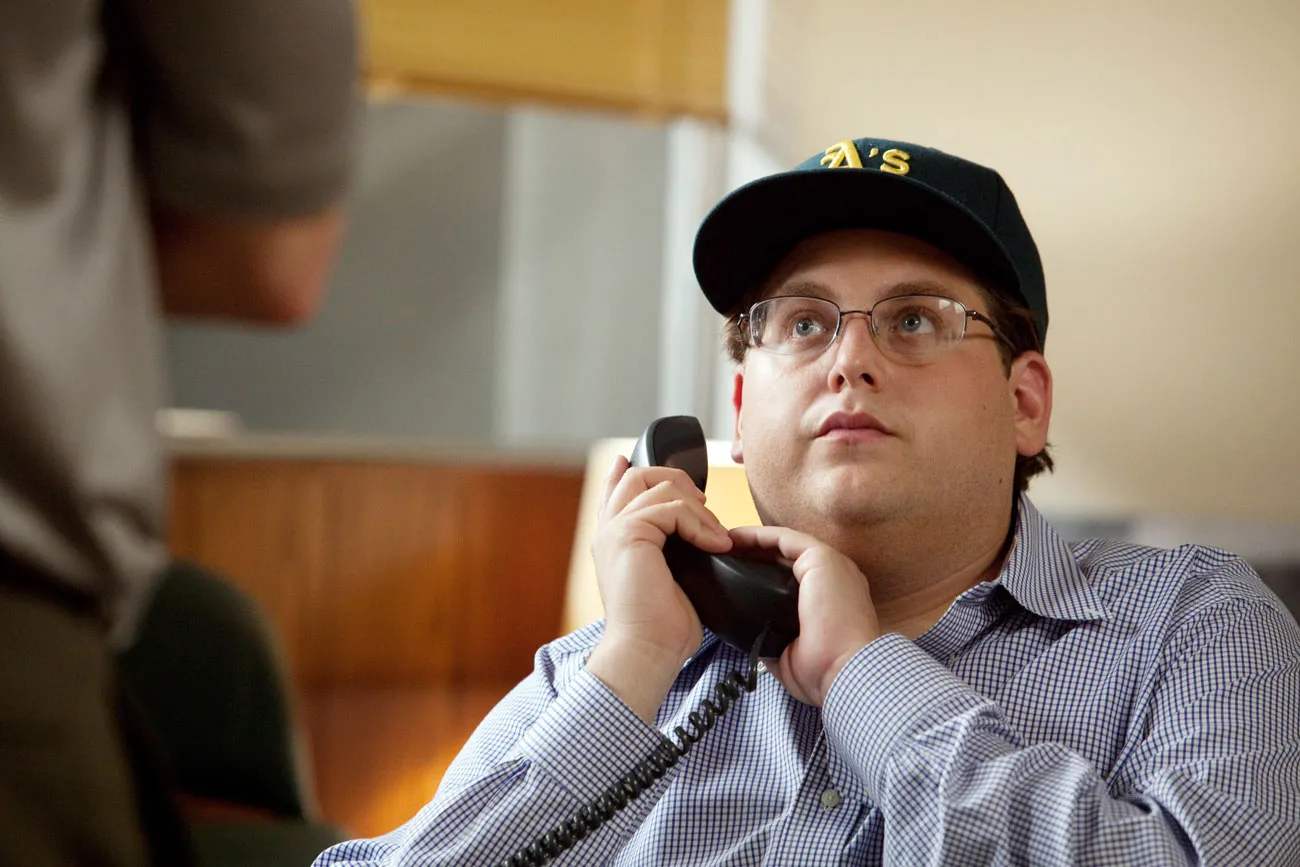What might the man be thinking about during this phone call? Given his focused expression and the context of being at a desk with a phone, he might be thinking about an important decision at work, discussing details of a project, or even negotiating a deal. His demeanor suggests a mix of concentration and concern, typical of business-related communications. 